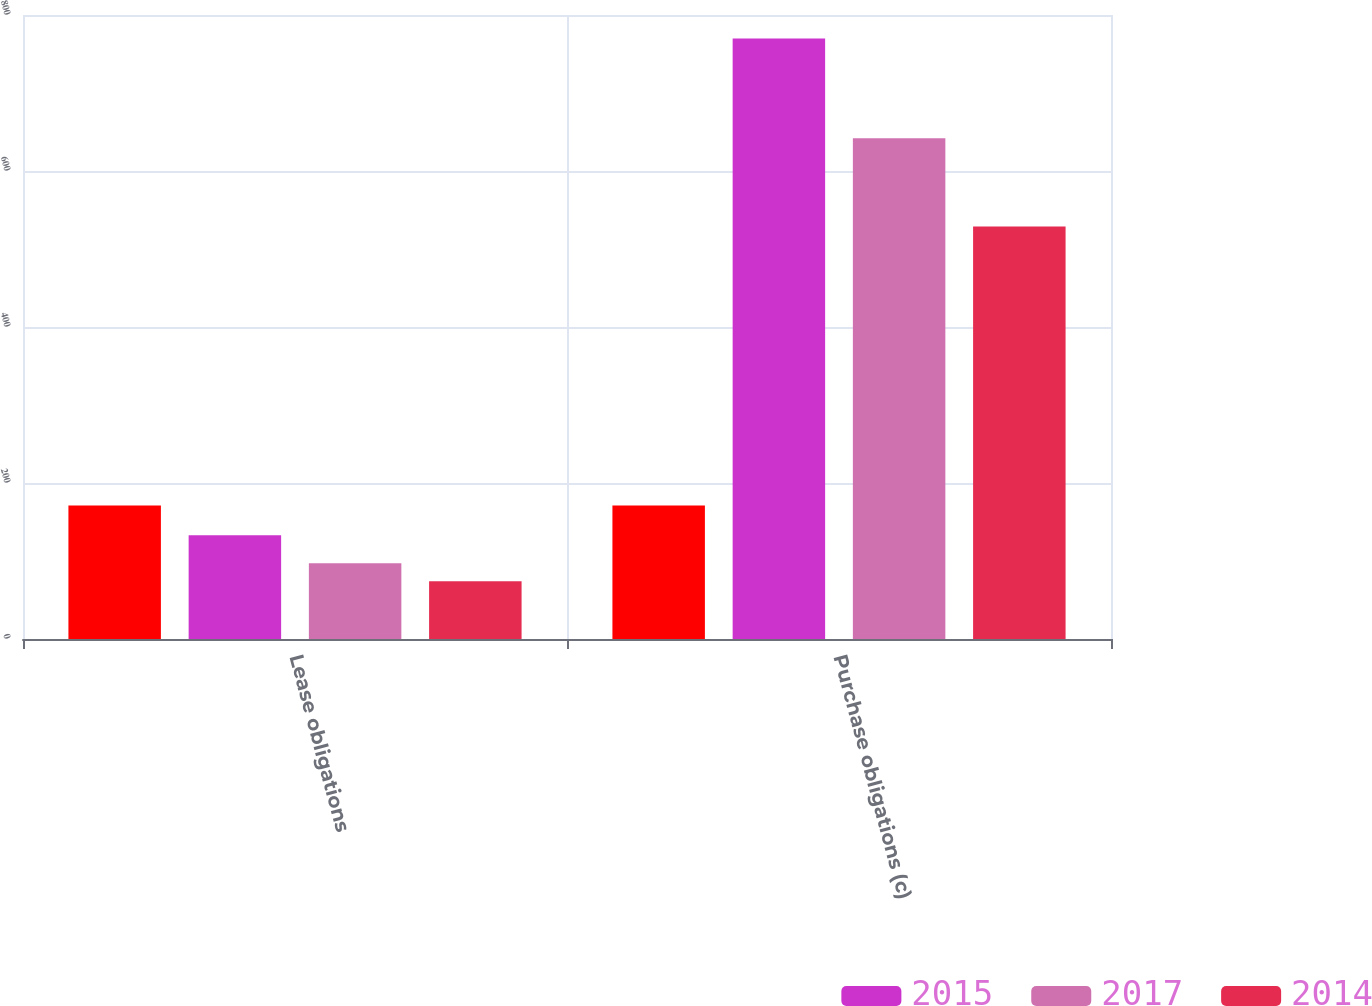Convert chart to OTSL. <chart><loc_0><loc_0><loc_500><loc_500><stacked_bar_chart><ecel><fcel>Lease obligations<fcel>Purchase obligations (c)<nl><fcel>nan<fcel>171<fcel>171<nl><fcel>2015<fcel>133<fcel>770<nl><fcel>2017<fcel>97<fcel>642<nl><fcel>2014<fcel>74<fcel>529<nl></chart> 